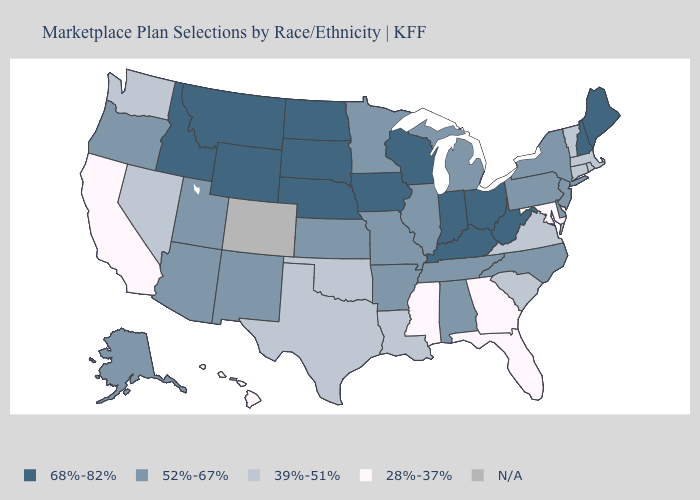What is the value of Washington?
Give a very brief answer. 39%-51%. Among the states that border Illinois , does Wisconsin have the lowest value?
Short answer required. No. Name the states that have a value in the range 68%-82%?
Give a very brief answer. Idaho, Indiana, Iowa, Kentucky, Maine, Montana, Nebraska, New Hampshire, North Dakota, Ohio, South Dakota, West Virginia, Wisconsin, Wyoming. What is the value of Wisconsin?
Concise answer only. 68%-82%. What is the value of Massachusetts?
Quick response, please. 39%-51%. Does the map have missing data?
Quick response, please. Yes. Does Alaska have the lowest value in the USA?
Short answer required. No. Name the states that have a value in the range 28%-37%?
Be succinct. California, Florida, Georgia, Hawaii, Maryland, Mississippi. What is the value of Arkansas?
Write a very short answer. 52%-67%. How many symbols are there in the legend?
Short answer required. 5. Name the states that have a value in the range N/A?
Be succinct. Colorado. What is the value of Utah?
Quick response, please. 52%-67%. Which states have the highest value in the USA?
Be succinct. Idaho, Indiana, Iowa, Kentucky, Maine, Montana, Nebraska, New Hampshire, North Dakota, Ohio, South Dakota, West Virginia, Wisconsin, Wyoming. Name the states that have a value in the range 68%-82%?
Give a very brief answer. Idaho, Indiana, Iowa, Kentucky, Maine, Montana, Nebraska, New Hampshire, North Dakota, Ohio, South Dakota, West Virginia, Wisconsin, Wyoming. Name the states that have a value in the range 52%-67%?
Be succinct. Alabama, Alaska, Arizona, Arkansas, Delaware, Illinois, Kansas, Michigan, Minnesota, Missouri, New Jersey, New Mexico, New York, North Carolina, Oregon, Pennsylvania, Tennessee, Utah. 